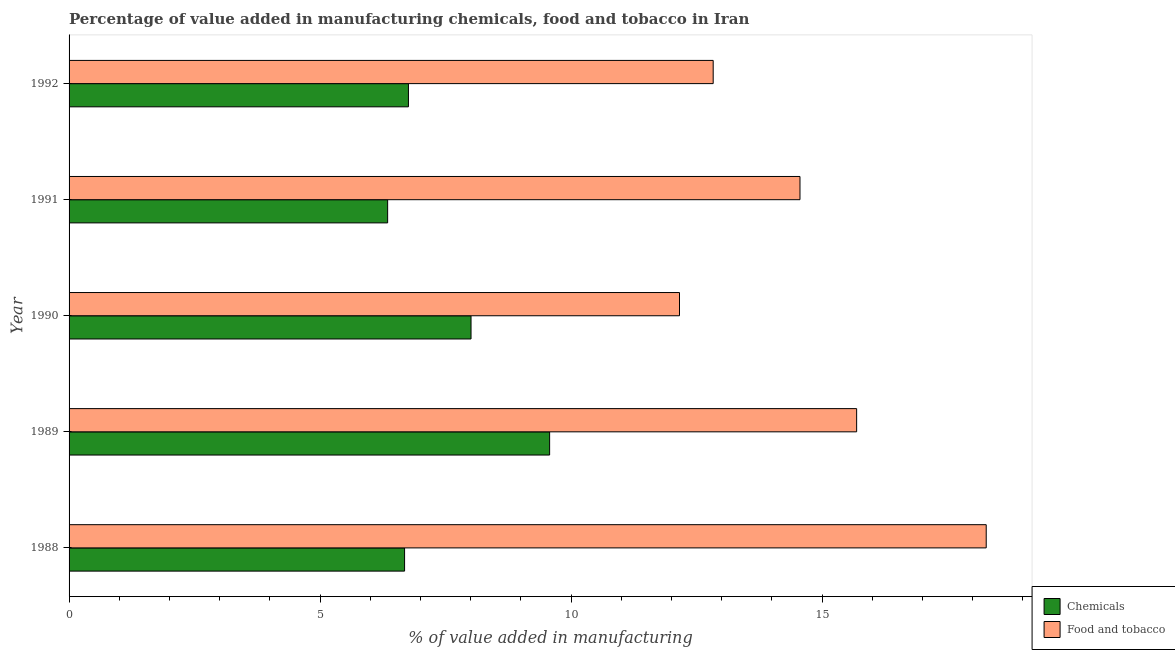How many different coloured bars are there?
Your answer should be very brief. 2. How many groups of bars are there?
Your response must be concise. 5. Are the number of bars on each tick of the Y-axis equal?
Make the answer very short. Yes. How many bars are there on the 2nd tick from the top?
Your response must be concise. 2. How many bars are there on the 1st tick from the bottom?
Provide a succinct answer. 2. What is the label of the 3rd group of bars from the top?
Your response must be concise. 1990. What is the value added by  manufacturing chemicals in 1990?
Make the answer very short. 8.01. Across all years, what is the maximum value added by manufacturing food and tobacco?
Provide a short and direct response. 18.27. Across all years, what is the minimum value added by  manufacturing chemicals?
Keep it short and to the point. 6.35. What is the total value added by manufacturing food and tobacco in the graph?
Make the answer very short. 73.5. What is the difference between the value added by manufacturing food and tobacco in 1989 and that in 1992?
Make the answer very short. 2.86. What is the difference between the value added by  manufacturing chemicals in 1992 and the value added by manufacturing food and tobacco in 1989?
Keep it short and to the point. -8.93. What is the average value added by  manufacturing chemicals per year?
Your answer should be very brief. 7.47. In the year 1991, what is the difference between the value added by manufacturing food and tobacco and value added by  manufacturing chemicals?
Offer a very short reply. 8.21. What is the ratio of the value added by manufacturing food and tobacco in 1989 to that in 1991?
Your answer should be compact. 1.08. Is the difference between the value added by  manufacturing chemicals in 1988 and 1991 greater than the difference between the value added by manufacturing food and tobacco in 1988 and 1991?
Provide a succinct answer. No. What is the difference between the highest and the second highest value added by  manufacturing chemicals?
Provide a succinct answer. 1.56. What is the difference between the highest and the lowest value added by manufacturing food and tobacco?
Your response must be concise. 6.11. What does the 2nd bar from the top in 1992 represents?
Make the answer very short. Chemicals. What does the 1st bar from the bottom in 1990 represents?
Your response must be concise. Chemicals. How many bars are there?
Keep it short and to the point. 10. Are all the bars in the graph horizontal?
Your response must be concise. Yes. Where does the legend appear in the graph?
Offer a terse response. Bottom right. How many legend labels are there?
Keep it short and to the point. 2. What is the title of the graph?
Give a very brief answer. Percentage of value added in manufacturing chemicals, food and tobacco in Iran. Does "Number of arrivals" appear as one of the legend labels in the graph?
Provide a succinct answer. No. What is the label or title of the X-axis?
Provide a succinct answer. % of value added in manufacturing. What is the % of value added in manufacturing in Chemicals in 1988?
Provide a short and direct response. 6.68. What is the % of value added in manufacturing of Food and tobacco in 1988?
Provide a succinct answer. 18.27. What is the % of value added in manufacturing of Chemicals in 1989?
Ensure brevity in your answer.  9.57. What is the % of value added in manufacturing in Food and tobacco in 1989?
Keep it short and to the point. 15.69. What is the % of value added in manufacturing in Chemicals in 1990?
Your response must be concise. 8.01. What is the % of value added in manufacturing in Food and tobacco in 1990?
Offer a very short reply. 12.16. What is the % of value added in manufacturing in Chemicals in 1991?
Your answer should be very brief. 6.35. What is the % of value added in manufacturing of Food and tobacco in 1991?
Your answer should be compact. 14.56. What is the % of value added in manufacturing in Chemicals in 1992?
Your response must be concise. 6.76. What is the % of value added in manufacturing of Food and tobacco in 1992?
Offer a terse response. 12.83. Across all years, what is the maximum % of value added in manufacturing of Chemicals?
Your answer should be very brief. 9.57. Across all years, what is the maximum % of value added in manufacturing in Food and tobacco?
Offer a terse response. 18.27. Across all years, what is the minimum % of value added in manufacturing in Chemicals?
Your answer should be compact. 6.35. Across all years, what is the minimum % of value added in manufacturing in Food and tobacco?
Keep it short and to the point. 12.16. What is the total % of value added in manufacturing in Chemicals in the graph?
Make the answer very short. 37.37. What is the total % of value added in manufacturing in Food and tobacco in the graph?
Ensure brevity in your answer.  73.5. What is the difference between the % of value added in manufacturing in Chemicals in 1988 and that in 1989?
Make the answer very short. -2.89. What is the difference between the % of value added in manufacturing of Food and tobacco in 1988 and that in 1989?
Give a very brief answer. 2.58. What is the difference between the % of value added in manufacturing of Chemicals in 1988 and that in 1990?
Ensure brevity in your answer.  -1.32. What is the difference between the % of value added in manufacturing of Food and tobacco in 1988 and that in 1990?
Your response must be concise. 6.11. What is the difference between the % of value added in manufacturing in Chemicals in 1988 and that in 1991?
Give a very brief answer. 0.34. What is the difference between the % of value added in manufacturing of Food and tobacco in 1988 and that in 1991?
Your answer should be compact. 3.71. What is the difference between the % of value added in manufacturing of Chemicals in 1988 and that in 1992?
Your response must be concise. -0.08. What is the difference between the % of value added in manufacturing in Food and tobacco in 1988 and that in 1992?
Your response must be concise. 5.44. What is the difference between the % of value added in manufacturing of Chemicals in 1989 and that in 1990?
Your answer should be compact. 1.57. What is the difference between the % of value added in manufacturing in Food and tobacco in 1989 and that in 1990?
Give a very brief answer. 3.53. What is the difference between the % of value added in manufacturing in Chemicals in 1989 and that in 1991?
Provide a short and direct response. 3.23. What is the difference between the % of value added in manufacturing in Food and tobacco in 1989 and that in 1991?
Make the answer very short. 1.13. What is the difference between the % of value added in manufacturing of Chemicals in 1989 and that in 1992?
Keep it short and to the point. 2.81. What is the difference between the % of value added in manufacturing in Food and tobacco in 1989 and that in 1992?
Offer a very short reply. 2.86. What is the difference between the % of value added in manufacturing in Chemicals in 1990 and that in 1991?
Provide a short and direct response. 1.66. What is the difference between the % of value added in manufacturing in Food and tobacco in 1990 and that in 1991?
Give a very brief answer. -2.4. What is the difference between the % of value added in manufacturing of Chemicals in 1990 and that in 1992?
Make the answer very short. 1.25. What is the difference between the % of value added in manufacturing of Food and tobacco in 1990 and that in 1992?
Offer a very short reply. -0.67. What is the difference between the % of value added in manufacturing of Chemicals in 1991 and that in 1992?
Your answer should be very brief. -0.41. What is the difference between the % of value added in manufacturing in Food and tobacco in 1991 and that in 1992?
Give a very brief answer. 1.73. What is the difference between the % of value added in manufacturing of Chemicals in 1988 and the % of value added in manufacturing of Food and tobacco in 1989?
Your response must be concise. -9. What is the difference between the % of value added in manufacturing in Chemicals in 1988 and the % of value added in manufacturing in Food and tobacco in 1990?
Your answer should be compact. -5.48. What is the difference between the % of value added in manufacturing of Chemicals in 1988 and the % of value added in manufacturing of Food and tobacco in 1991?
Provide a succinct answer. -7.88. What is the difference between the % of value added in manufacturing in Chemicals in 1988 and the % of value added in manufacturing in Food and tobacco in 1992?
Offer a very short reply. -6.15. What is the difference between the % of value added in manufacturing of Chemicals in 1989 and the % of value added in manufacturing of Food and tobacco in 1990?
Ensure brevity in your answer.  -2.59. What is the difference between the % of value added in manufacturing in Chemicals in 1989 and the % of value added in manufacturing in Food and tobacco in 1991?
Provide a short and direct response. -4.99. What is the difference between the % of value added in manufacturing of Chemicals in 1989 and the % of value added in manufacturing of Food and tobacco in 1992?
Your response must be concise. -3.26. What is the difference between the % of value added in manufacturing of Chemicals in 1990 and the % of value added in manufacturing of Food and tobacco in 1991?
Your response must be concise. -6.55. What is the difference between the % of value added in manufacturing of Chemicals in 1990 and the % of value added in manufacturing of Food and tobacco in 1992?
Your answer should be very brief. -4.82. What is the difference between the % of value added in manufacturing in Chemicals in 1991 and the % of value added in manufacturing in Food and tobacco in 1992?
Your answer should be compact. -6.48. What is the average % of value added in manufacturing in Chemicals per year?
Give a very brief answer. 7.47. What is the average % of value added in manufacturing in Food and tobacco per year?
Your response must be concise. 14.7. In the year 1988, what is the difference between the % of value added in manufacturing of Chemicals and % of value added in manufacturing of Food and tobacco?
Give a very brief answer. -11.59. In the year 1989, what is the difference between the % of value added in manufacturing of Chemicals and % of value added in manufacturing of Food and tobacco?
Ensure brevity in your answer.  -6.12. In the year 1990, what is the difference between the % of value added in manufacturing in Chemicals and % of value added in manufacturing in Food and tobacco?
Keep it short and to the point. -4.15. In the year 1991, what is the difference between the % of value added in manufacturing in Chemicals and % of value added in manufacturing in Food and tobacco?
Ensure brevity in your answer.  -8.21. In the year 1992, what is the difference between the % of value added in manufacturing in Chemicals and % of value added in manufacturing in Food and tobacco?
Your answer should be compact. -6.07. What is the ratio of the % of value added in manufacturing in Chemicals in 1988 to that in 1989?
Make the answer very short. 0.7. What is the ratio of the % of value added in manufacturing in Food and tobacco in 1988 to that in 1989?
Your answer should be very brief. 1.16. What is the ratio of the % of value added in manufacturing in Chemicals in 1988 to that in 1990?
Your answer should be very brief. 0.83. What is the ratio of the % of value added in manufacturing in Food and tobacco in 1988 to that in 1990?
Your answer should be very brief. 1.5. What is the ratio of the % of value added in manufacturing in Chemicals in 1988 to that in 1991?
Your response must be concise. 1.05. What is the ratio of the % of value added in manufacturing in Food and tobacco in 1988 to that in 1991?
Offer a terse response. 1.25. What is the ratio of the % of value added in manufacturing of Food and tobacco in 1988 to that in 1992?
Keep it short and to the point. 1.42. What is the ratio of the % of value added in manufacturing of Chemicals in 1989 to that in 1990?
Offer a terse response. 1.2. What is the ratio of the % of value added in manufacturing in Food and tobacco in 1989 to that in 1990?
Your response must be concise. 1.29. What is the ratio of the % of value added in manufacturing of Chemicals in 1989 to that in 1991?
Give a very brief answer. 1.51. What is the ratio of the % of value added in manufacturing of Food and tobacco in 1989 to that in 1991?
Ensure brevity in your answer.  1.08. What is the ratio of the % of value added in manufacturing of Chemicals in 1989 to that in 1992?
Offer a very short reply. 1.42. What is the ratio of the % of value added in manufacturing in Food and tobacco in 1989 to that in 1992?
Provide a short and direct response. 1.22. What is the ratio of the % of value added in manufacturing of Chemicals in 1990 to that in 1991?
Offer a very short reply. 1.26. What is the ratio of the % of value added in manufacturing of Food and tobacco in 1990 to that in 1991?
Ensure brevity in your answer.  0.84. What is the ratio of the % of value added in manufacturing of Chemicals in 1990 to that in 1992?
Your answer should be compact. 1.18. What is the ratio of the % of value added in manufacturing of Food and tobacco in 1990 to that in 1992?
Give a very brief answer. 0.95. What is the ratio of the % of value added in manufacturing of Chemicals in 1991 to that in 1992?
Your response must be concise. 0.94. What is the ratio of the % of value added in manufacturing of Food and tobacco in 1991 to that in 1992?
Your response must be concise. 1.13. What is the difference between the highest and the second highest % of value added in manufacturing of Chemicals?
Provide a short and direct response. 1.57. What is the difference between the highest and the second highest % of value added in manufacturing of Food and tobacco?
Give a very brief answer. 2.58. What is the difference between the highest and the lowest % of value added in manufacturing of Chemicals?
Provide a short and direct response. 3.23. What is the difference between the highest and the lowest % of value added in manufacturing of Food and tobacco?
Make the answer very short. 6.11. 